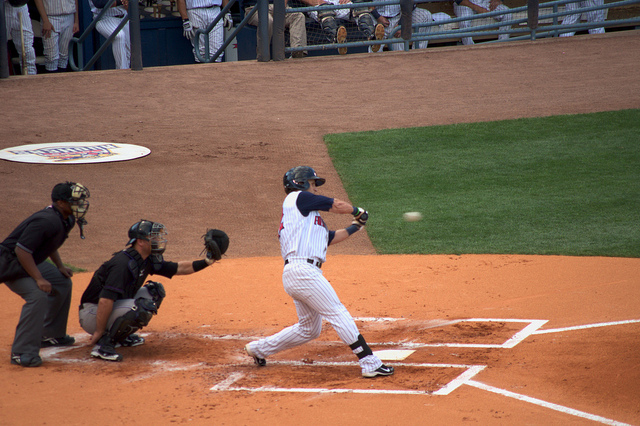Can you describe the setting? The image captures a moment from a professional baseball game. We can see the batter's box, home plate, and part of the diamond, along with some players and officials in the background. What team might the batter belong to? The batter is wearing a striped uniform which could indicate a specific baseball team, although the exact team is not identified in the image. 